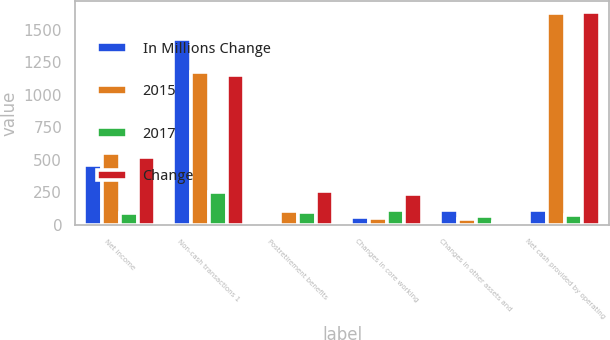<chart> <loc_0><loc_0><loc_500><loc_500><stacked_bar_chart><ecel><fcel>Net income<fcel>Non-cash transactions 1<fcel>Postretirement benefits<fcel>Changes in core working<fcel>Changes in other assets and<fcel>Net cash provided by operating<nl><fcel>In Millions Change<fcel>462<fcel>1429<fcel>12<fcel>63<fcel>111<fcel>113<nl><fcel>2015<fcel>553<fcel>1177<fcel>108<fcel>50<fcel>43<fcel>1629<nl><fcel>2017<fcel>91<fcel>252<fcel>96<fcel>113<fcel>68<fcel>76<nl><fcel>Change<fcel>525<fcel>1155<fcel>262<fcel>241<fcel>19<fcel>1640<nl></chart> 